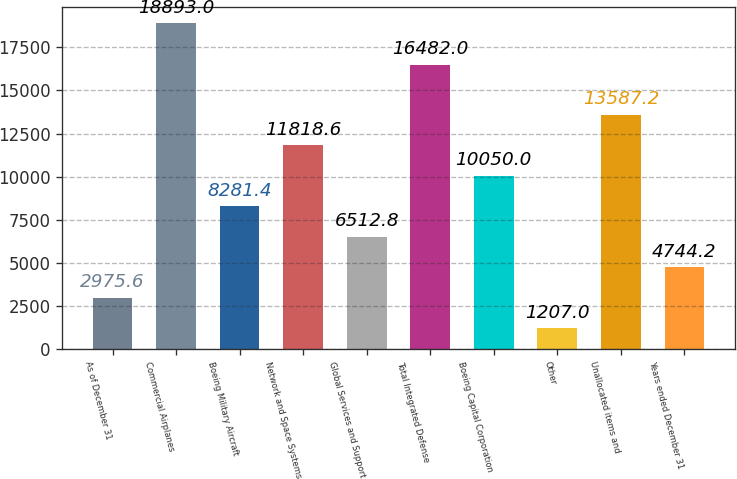Convert chart. <chart><loc_0><loc_0><loc_500><loc_500><bar_chart><fcel>As of December 31<fcel>Commercial Airplanes<fcel>Boeing Military Aircraft<fcel>Network and Space Systems<fcel>Global Services and Support<fcel>Total Integrated Defense<fcel>Boeing Capital Corporation<fcel>Other<fcel>Unallocated items and<fcel>Years ended December 31<nl><fcel>2975.6<fcel>18893<fcel>8281.4<fcel>11818.6<fcel>6512.8<fcel>16482<fcel>10050<fcel>1207<fcel>13587.2<fcel>4744.2<nl></chart> 